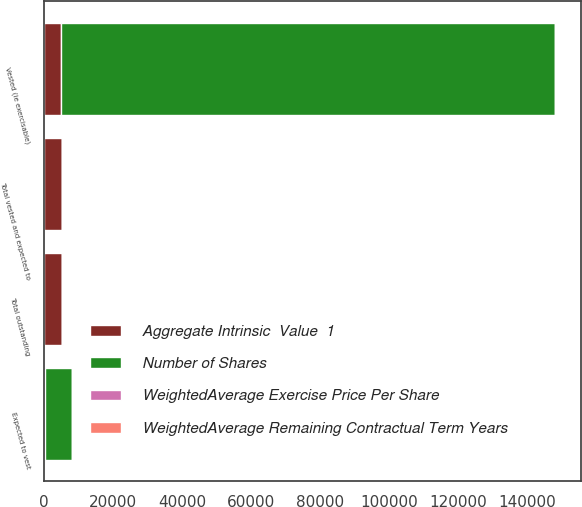Convert chart. <chart><loc_0><loc_0><loc_500><loc_500><stacked_bar_chart><ecel><fcel>Vested (ie exercisable)<fcel>Expected to vest<fcel>Total vested and expected to<fcel>Total outstanding<nl><fcel>Aggregate Intrinsic  Value  1<fcel>4935<fcel>326<fcel>5261<fcel>5280<nl><fcel>WeightedAverage Remaining Contractual Term Years<fcel>24.87<fcel>30.36<fcel>25.21<fcel>25.22<nl><fcel>WeightedAverage Exercise Price Per Share<fcel>2.2<fcel>4.1<fcel>2.3<fcel>2.3<nl><fcel>Number of Shares<fcel>142968<fcel>7648<fcel>27.79<fcel>27.79<nl></chart> 